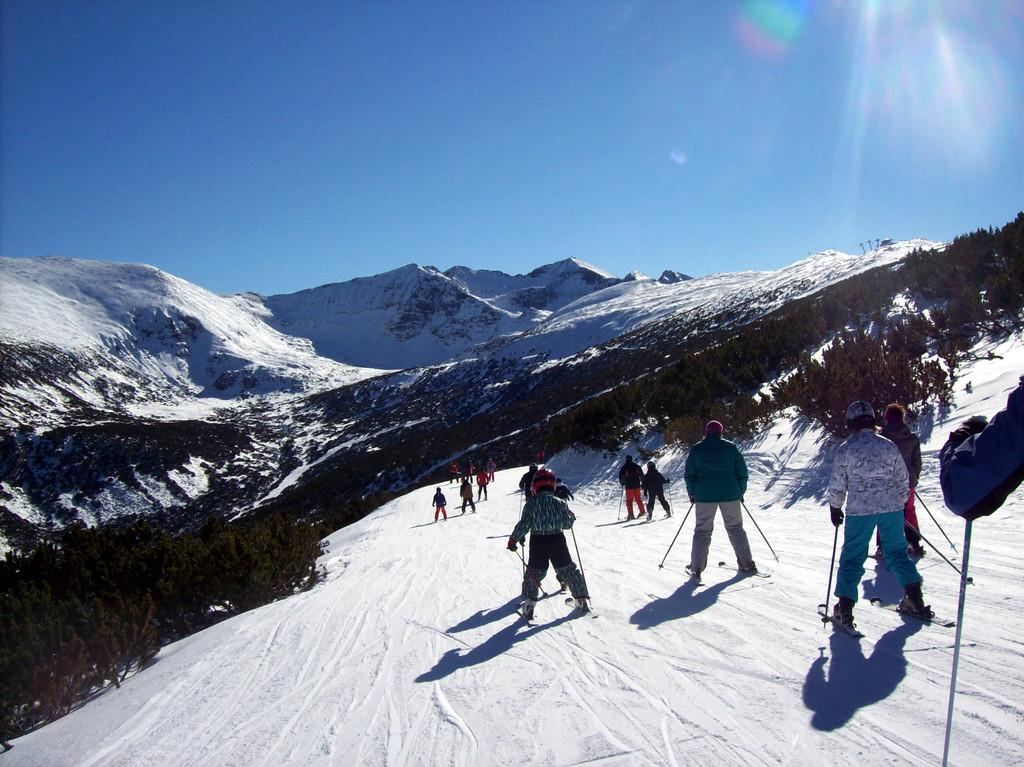What activity are the people in the image engaged in? There are many people skiing in the image. What can be seen in the distance behind the skiers? There are mountains in the background of the image. What is the ground made of at the bottom of the image? There is snow at the bottom of the image. What type of prose can be heard being recited by the skiers in the image? There is no indication in the image that the skiers are reciting any prose, so it cannot be determined from the picture. 